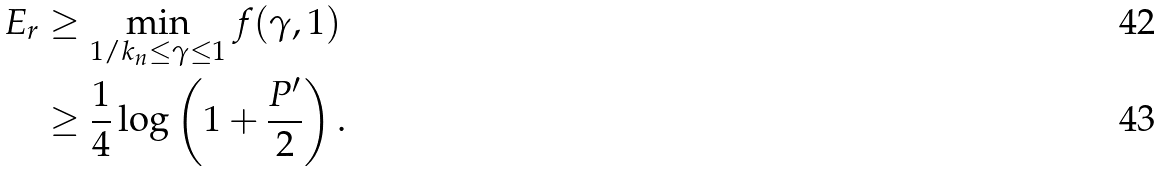Convert formula to latex. <formula><loc_0><loc_0><loc_500><loc_500>E _ { r } & \geq \min _ { 1 / k _ { n } \leq \gamma \leq 1 } f ( \gamma , 1 ) \\ & \geq \frac { 1 } { 4 } \log \left ( 1 + \frac { P ^ { \prime } } { 2 } \right ) .</formula> 